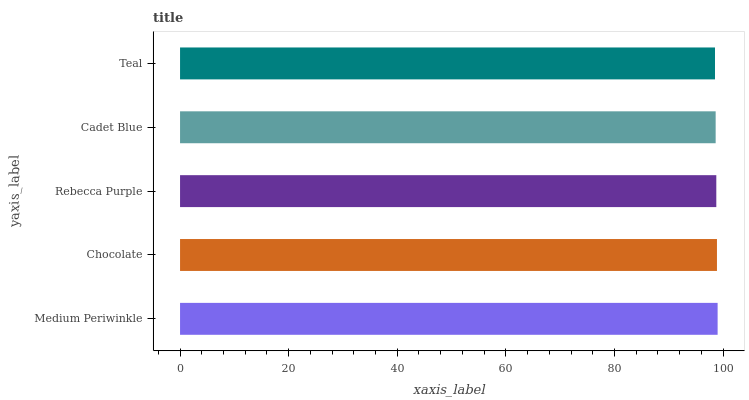Is Teal the minimum?
Answer yes or no. Yes. Is Medium Periwinkle the maximum?
Answer yes or no. Yes. Is Chocolate the minimum?
Answer yes or no. No. Is Chocolate the maximum?
Answer yes or no. No. Is Medium Periwinkle greater than Chocolate?
Answer yes or no. Yes. Is Chocolate less than Medium Periwinkle?
Answer yes or no. Yes. Is Chocolate greater than Medium Periwinkle?
Answer yes or no. No. Is Medium Periwinkle less than Chocolate?
Answer yes or no. No. Is Rebecca Purple the high median?
Answer yes or no. Yes. Is Rebecca Purple the low median?
Answer yes or no. Yes. Is Chocolate the high median?
Answer yes or no. No. Is Cadet Blue the low median?
Answer yes or no. No. 